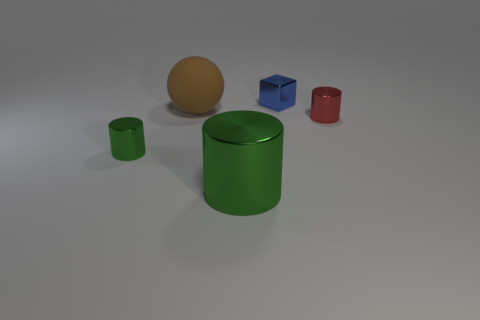The block that is made of the same material as the large cylinder is what color? The block sharing the same lustrous sheen as the large green cylinder is colored blue. 